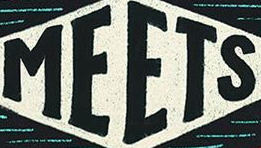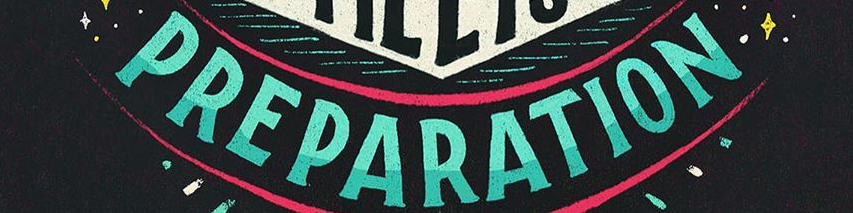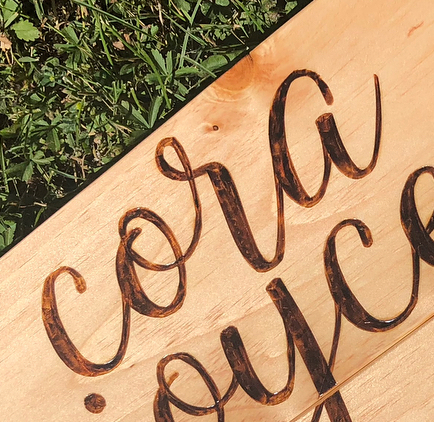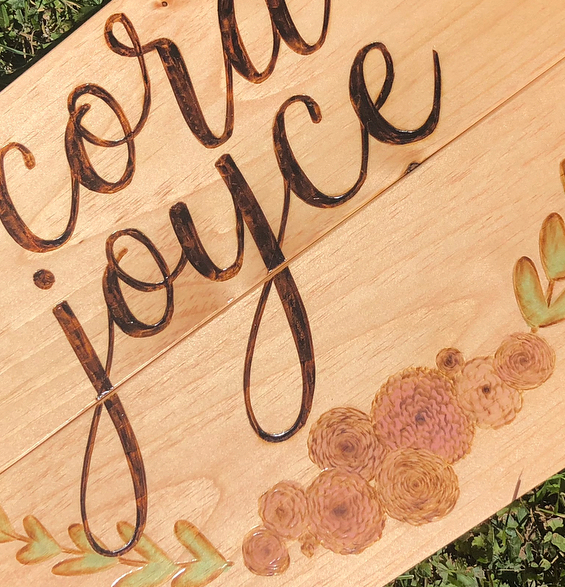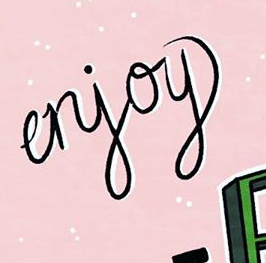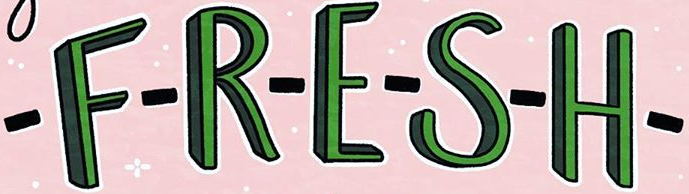What text appears in these images from left to right, separated by a semicolon? MEETS; PREPARATION; cora; joyce; erjoy; -F-R-E-S-H- 